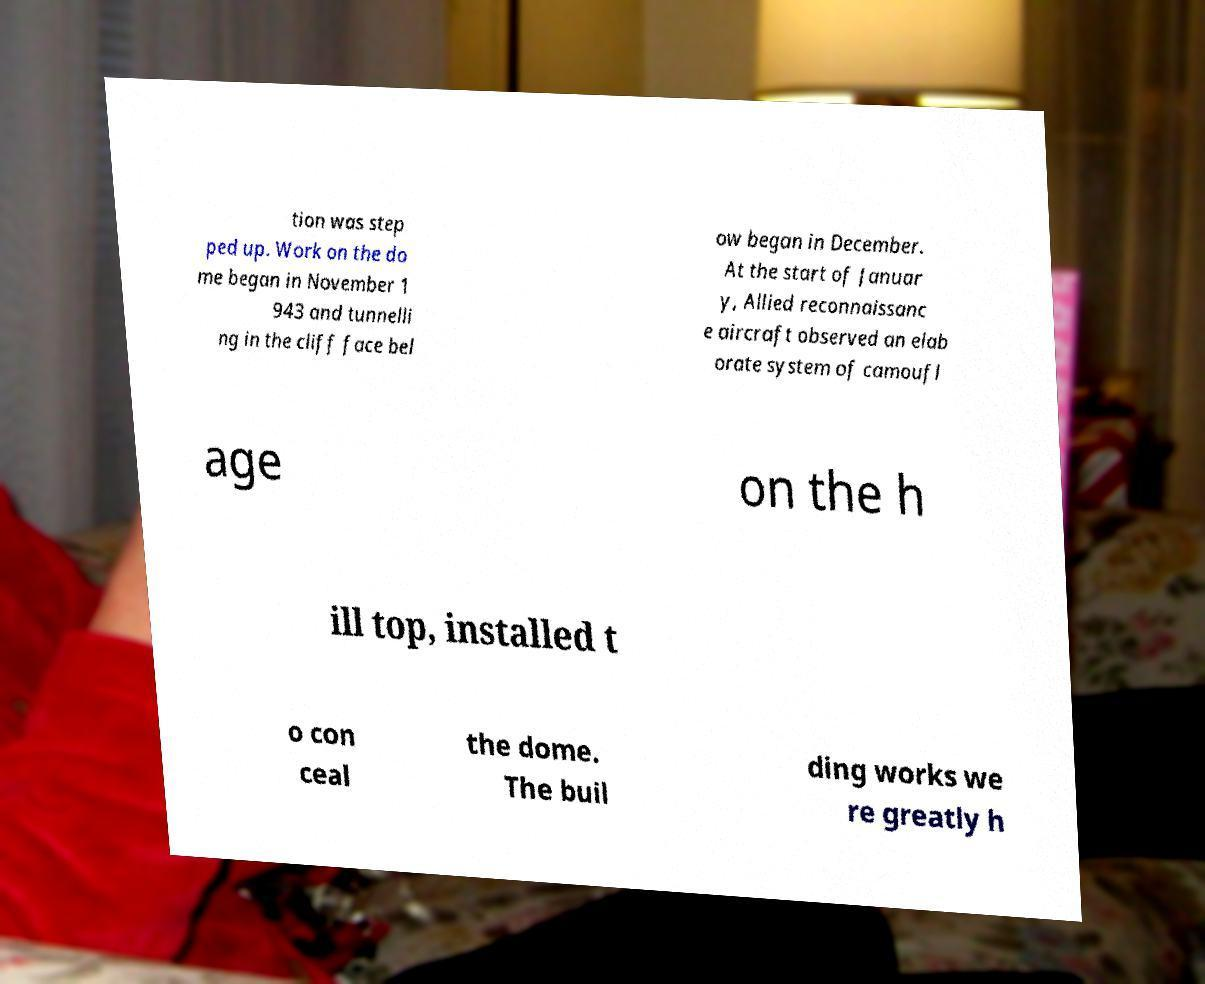What messages or text are displayed in this image? I need them in a readable, typed format. tion was step ped up. Work on the do me began in November 1 943 and tunnelli ng in the cliff face bel ow began in December. At the start of Januar y, Allied reconnaissanc e aircraft observed an elab orate system of camoufl age on the h ill top, installed t o con ceal the dome. The buil ding works we re greatly h 